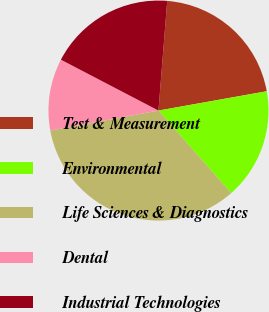<chart> <loc_0><loc_0><loc_500><loc_500><pie_chart><fcel>Test & Measurement<fcel>Environmental<fcel>Life Sciences & Diagnostics<fcel>Dental<fcel>Industrial Technologies<nl><fcel>20.92%<fcel>16.31%<fcel>33.59%<fcel>10.56%<fcel>18.62%<nl></chart> 